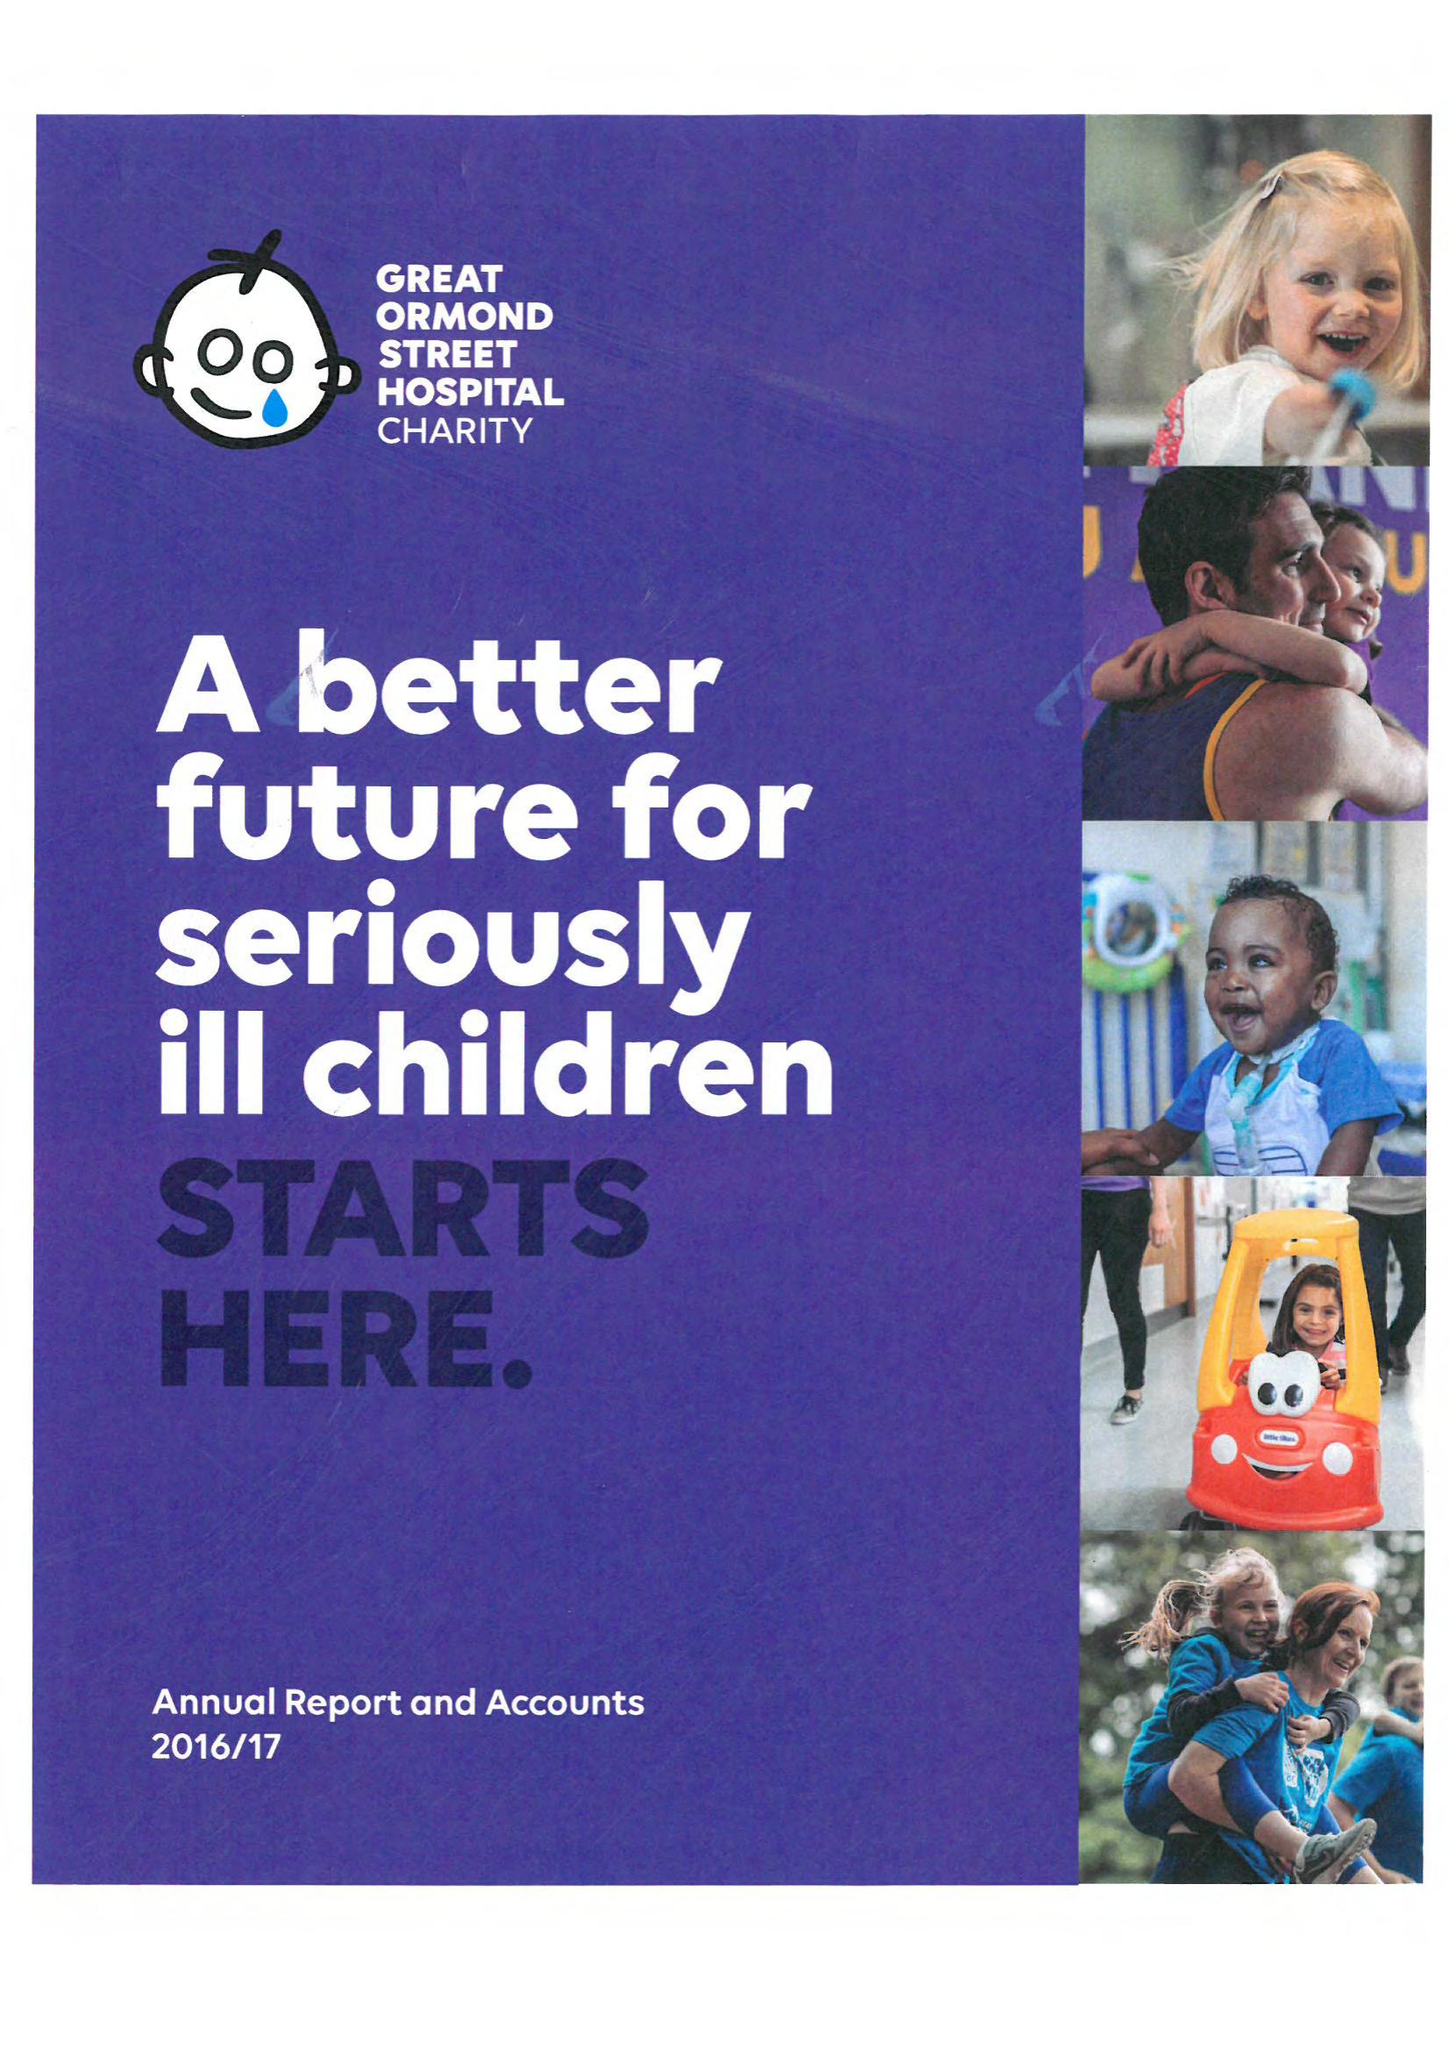What is the value for the charity_number?
Answer the question using a single word or phrase. 1160024 